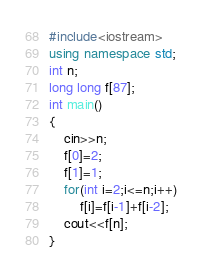<code> <loc_0><loc_0><loc_500><loc_500><_C++_>#include<iostream>
using namespace std;
int n;
long long f[87];
int main()
{
    cin>>n;
    f[0]=2;
    f[1]=1;
    for(int i=2;i<=n;i++)
        f[i]=f[i-1]+f[i-2];
    cout<<f[n];
}</code> 